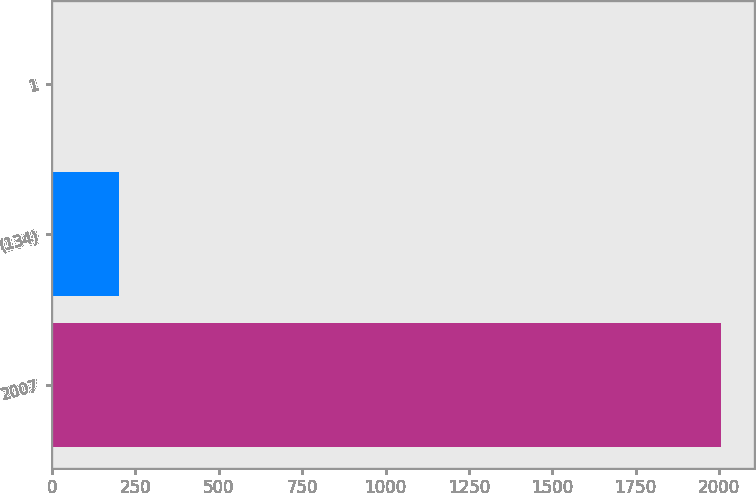Convert chart. <chart><loc_0><loc_0><loc_500><loc_500><bar_chart><fcel>2007<fcel>(134)<fcel>1<nl><fcel>2005<fcel>201.4<fcel>1<nl></chart> 